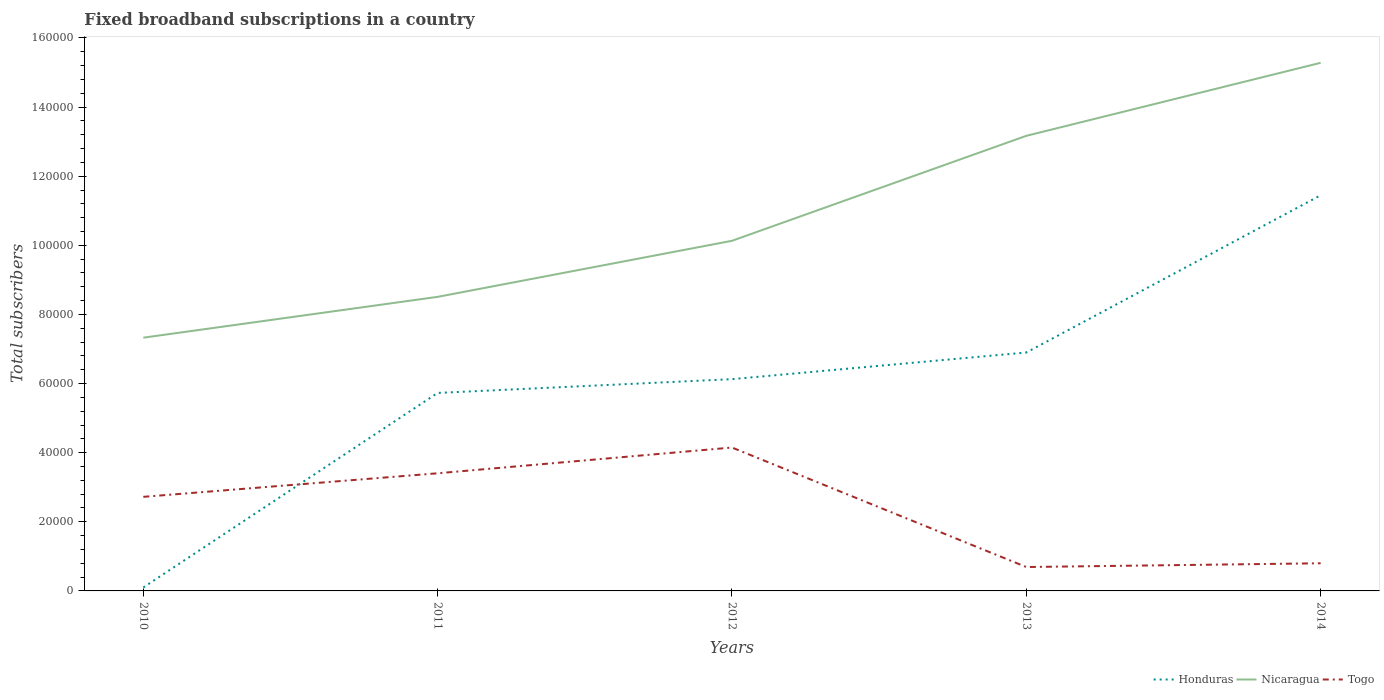How many different coloured lines are there?
Keep it short and to the point. 3. Does the line corresponding to Nicaragua intersect with the line corresponding to Togo?
Give a very brief answer. No. Across all years, what is the maximum number of broadband subscriptions in Honduras?
Your answer should be very brief. 1000. In which year was the number of broadband subscriptions in Nicaragua maximum?
Your response must be concise. 2010. What is the total number of broadband subscriptions in Togo in the graph?
Keep it short and to the point. 2.71e+04. What is the difference between the highest and the second highest number of broadband subscriptions in Togo?
Your answer should be very brief. 3.46e+04. What is the difference between the highest and the lowest number of broadband subscriptions in Togo?
Provide a succinct answer. 3. How many years are there in the graph?
Provide a succinct answer. 5. What is the difference between two consecutive major ticks on the Y-axis?
Provide a succinct answer. 2.00e+04. Are the values on the major ticks of Y-axis written in scientific E-notation?
Offer a very short reply. No. How many legend labels are there?
Keep it short and to the point. 3. What is the title of the graph?
Give a very brief answer. Fixed broadband subscriptions in a country. What is the label or title of the X-axis?
Provide a short and direct response. Years. What is the label or title of the Y-axis?
Offer a terse response. Total subscribers. What is the Total subscribers of Nicaragua in 2010?
Provide a short and direct response. 7.33e+04. What is the Total subscribers of Togo in 2010?
Provide a short and direct response. 2.72e+04. What is the Total subscribers of Honduras in 2011?
Your response must be concise. 5.73e+04. What is the Total subscribers of Nicaragua in 2011?
Provide a succinct answer. 8.51e+04. What is the Total subscribers of Togo in 2011?
Provide a short and direct response. 3.40e+04. What is the Total subscribers of Honduras in 2012?
Your answer should be very brief. 6.13e+04. What is the Total subscribers in Nicaragua in 2012?
Provide a short and direct response. 1.01e+05. What is the Total subscribers in Togo in 2012?
Provide a short and direct response. 4.15e+04. What is the Total subscribers in Honduras in 2013?
Offer a very short reply. 6.90e+04. What is the Total subscribers in Nicaragua in 2013?
Ensure brevity in your answer.  1.32e+05. What is the Total subscribers in Togo in 2013?
Provide a succinct answer. 6915. What is the Total subscribers in Honduras in 2014?
Offer a very short reply. 1.14e+05. What is the Total subscribers in Nicaragua in 2014?
Offer a terse response. 1.53e+05. What is the Total subscribers in Togo in 2014?
Offer a very short reply. 8000. Across all years, what is the maximum Total subscribers of Honduras?
Your response must be concise. 1.14e+05. Across all years, what is the maximum Total subscribers in Nicaragua?
Provide a succinct answer. 1.53e+05. Across all years, what is the maximum Total subscribers in Togo?
Your response must be concise. 4.15e+04. Across all years, what is the minimum Total subscribers in Honduras?
Make the answer very short. 1000. Across all years, what is the minimum Total subscribers of Nicaragua?
Your answer should be very brief. 7.33e+04. Across all years, what is the minimum Total subscribers of Togo?
Make the answer very short. 6915. What is the total Total subscribers of Honduras in the graph?
Offer a terse response. 3.03e+05. What is the total Total subscribers of Nicaragua in the graph?
Provide a succinct answer. 5.44e+05. What is the total Total subscribers of Togo in the graph?
Keep it short and to the point. 1.18e+05. What is the difference between the Total subscribers of Honduras in 2010 and that in 2011?
Offer a terse response. -5.63e+04. What is the difference between the Total subscribers of Nicaragua in 2010 and that in 2011?
Keep it short and to the point. -1.18e+04. What is the difference between the Total subscribers in Togo in 2010 and that in 2011?
Keep it short and to the point. -6814. What is the difference between the Total subscribers of Honduras in 2010 and that in 2012?
Give a very brief answer. -6.03e+04. What is the difference between the Total subscribers of Nicaragua in 2010 and that in 2012?
Your response must be concise. -2.80e+04. What is the difference between the Total subscribers in Togo in 2010 and that in 2012?
Give a very brief answer. -1.43e+04. What is the difference between the Total subscribers in Honduras in 2010 and that in 2013?
Make the answer very short. -6.80e+04. What is the difference between the Total subscribers in Nicaragua in 2010 and that in 2013?
Provide a succinct answer. -5.84e+04. What is the difference between the Total subscribers in Togo in 2010 and that in 2013?
Offer a terse response. 2.03e+04. What is the difference between the Total subscribers of Honduras in 2010 and that in 2014?
Keep it short and to the point. -1.13e+05. What is the difference between the Total subscribers in Nicaragua in 2010 and that in 2014?
Your answer should be very brief. -7.95e+04. What is the difference between the Total subscribers of Togo in 2010 and that in 2014?
Your response must be concise. 1.92e+04. What is the difference between the Total subscribers of Honduras in 2011 and that in 2012?
Give a very brief answer. -3987. What is the difference between the Total subscribers in Nicaragua in 2011 and that in 2012?
Provide a succinct answer. -1.62e+04. What is the difference between the Total subscribers in Togo in 2011 and that in 2012?
Offer a very short reply. -7454. What is the difference between the Total subscribers of Honduras in 2011 and that in 2013?
Your response must be concise. -1.17e+04. What is the difference between the Total subscribers of Nicaragua in 2011 and that in 2013?
Your response must be concise. -4.66e+04. What is the difference between the Total subscribers of Togo in 2011 and that in 2013?
Ensure brevity in your answer.  2.71e+04. What is the difference between the Total subscribers in Honduras in 2011 and that in 2014?
Provide a succinct answer. -5.72e+04. What is the difference between the Total subscribers of Nicaragua in 2011 and that in 2014?
Your answer should be very brief. -6.77e+04. What is the difference between the Total subscribers of Togo in 2011 and that in 2014?
Offer a very short reply. 2.60e+04. What is the difference between the Total subscribers in Honduras in 2012 and that in 2013?
Offer a terse response. -7714. What is the difference between the Total subscribers of Nicaragua in 2012 and that in 2013?
Give a very brief answer. -3.04e+04. What is the difference between the Total subscribers in Togo in 2012 and that in 2013?
Offer a very short reply. 3.46e+04. What is the difference between the Total subscribers in Honduras in 2012 and that in 2014?
Ensure brevity in your answer.  -5.32e+04. What is the difference between the Total subscribers of Nicaragua in 2012 and that in 2014?
Give a very brief answer. -5.15e+04. What is the difference between the Total subscribers in Togo in 2012 and that in 2014?
Keep it short and to the point. 3.35e+04. What is the difference between the Total subscribers of Honduras in 2013 and that in 2014?
Provide a short and direct response. -4.55e+04. What is the difference between the Total subscribers in Nicaragua in 2013 and that in 2014?
Your answer should be compact. -2.11e+04. What is the difference between the Total subscribers of Togo in 2013 and that in 2014?
Keep it short and to the point. -1085. What is the difference between the Total subscribers in Honduras in 2010 and the Total subscribers in Nicaragua in 2011?
Provide a succinct answer. -8.41e+04. What is the difference between the Total subscribers of Honduras in 2010 and the Total subscribers of Togo in 2011?
Ensure brevity in your answer.  -3.30e+04. What is the difference between the Total subscribers of Nicaragua in 2010 and the Total subscribers of Togo in 2011?
Your answer should be very brief. 3.92e+04. What is the difference between the Total subscribers in Honduras in 2010 and the Total subscribers in Nicaragua in 2012?
Provide a short and direct response. -1.00e+05. What is the difference between the Total subscribers in Honduras in 2010 and the Total subscribers in Togo in 2012?
Make the answer very short. -4.05e+04. What is the difference between the Total subscribers in Nicaragua in 2010 and the Total subscribers in Togo in 2012?
Your answer should be very brief. 3.18e+04. What is the difference between the Total subscribers of Honduras in 2010 and the Total subscribers of Nicaragua in 2013?
Give a very brief answer. -1.31e+05. What is the difference between the Total subscribers of Honduras in 2010 and the Total subscribers of Togo in 2013?
Ensure brevity in your answer.  -5915. What is the difference between the Total subscribers of Nicaragua in 2010 and the Total subscribers of Togo in 2013?
Ensure brevity in your answer.  6.64e+04. What is the difference between the Total subscribers of Honduras in 2010 and the Total subscribers of Nicaragua in 2014?
Offer a terse response. -1.52e+05. What is the difference between the Total subscribers in Honduras in 2010 and the Total subscribers in Togo in 2014?
Make the answer very short. -7000. What is the difference between the Total subscribers of Nicaragua in 2010 and the Total subscribers of Togo in 2014?
Give a very brief answer. 6.53e+04. What is the difference between the Total subscribers of Honduras in 2011 and the Total subscribers of Nicaragua in 2012?
Provide a short and direct response. -4.40e+04. What is the difference between the Total subscribers of Honduras in 2011 and the Total subscribers of Togo in 2012?
Keep it short and to the point. 1.58e+04. What is the difference between the Total subscribers of Nicaragua in 2011 and the Total subscribers of Togo in 2012?
Keep it short and to the point. 4.36e+04. What is the difference between the Total subscribers of Honduras in 2011 and the Total subscribers of Nicaragua in 2013?
Offer a terse response. -7.44e+04. What is the difference between the Total subscribers in Honduras in 2011 and the Total subscribers in Togo in 2013?
Offer a very short reply. 5.04e+04. What is the difference between the Total subscribers in Nicaragua in 2011 and the Total subscribers in Togo in 2013?
Give a very brief answer. 7.82e+04. What is the difference between the Total subscribers of Honduras in 2011 and the Total subscribers of Nicaragua in 2014?
Ensure brevity in your answer.  -9.55e+04. What is the difference between the Total subscribers in Honduras in 2011 and the Total subscribers in Togo in 2014?
Provide a succinct answer. 4.93e+04. What is the difference between the Total subscribers of Nicaragua in 2011 and the Total subscribers of Togo in 2014?
Keep it short and to the point. 7.71e+04. What is the difference between the Total subscribers in Honduras in 2012 and the Total subscribers in Nicaragua in 2013?
Offer a terse response. -7.04e+04. What is the difference between the Total subscribers in Honduras in 2012 and the Total subscribers in Togo in 2013?
Give a very brief answer. 5.44e+04. What is the difference between the Total subscribers of Nicaragua in 2012 and the Total subscribers of Togo in 2013?
Give a very brief answer. 9.44e+04. What is the difference between the Total subscribers of Honduras in 2012 and the Total subscribers of Nicaragua in 2014?
Your answer should be compact. -9.15e+04. What is the difference between the Total subscribers in Honduras in 2012 and the Total subscribers in Togo in 2014?
Keep it short and to the point. 5.33e+04. What is the difference between the Total subscribers in Nicaragua in 2012 and the Total subscribers in Togo in 2014?
Provide a short and direct response. 9.33e+04. What is the difference between the Total subscribers in Honduras in 2013 and the Total subscribers in Nicaragua in 2014?
Ensure brevity in your answer.  -8.38e+04. What is the difference between the Total subscribers of Honduras in 2013 and the Total subscribers of Togo in 2014?
Offer a terse response. 6.10e+04. What is the difference between the Total subscribers in Nicaragua in 2013 and the Total subscribers in Togo in 2014?
Offer a very short reply. 1.24e+05. What is the average Total subscribers in Honduras per year?
Your answer should be compact. 6.06e+04. What is the average Total subscribers of Nicaragua per year?
Offer a very short reply. 1.09e+05. What is the average Total subscribers in Togo per year?
Your response must be concise. 2.35e+04. In the year 2010, what is the difference between the Total subscribers in Honduras and Total subscribers in Nicaragua?
Your answer should be very brief. -7.23e+04. In the year 2010, what is the difference between the Total subscribers in Honduras and Total subscribers in Togo?
Make the answer very short. -2.62e+04. In the year 2010, what is the difference between the Total subscribers of Nicaragua and Total subscribers of Togo?
Your response must be concise. 4.61e+04. In the year 2011, what is the difference between the Total subscribers in Honduras and Total subscribers in Nicaragua?
Offer a terse response. -2.78e+04. In the year 2011, what is the difference between the Total subscribers in Honduras and Total subscribers in Togo?
Offer a very short reply. 2.33e+04. In the year 2011, what is the difference between the Total subscribers of Nicaragua and Total subscribers of Togo?
Your answer should be compact. 5.11e+04. In the year 2012, what is the difference between the Total subscribers of Honduras and Total subscribers of Nicaragua?
Offer a terse response. -4.00e+04. In the year 2012, what is the difference between the Total subscribers in Honduras and Total subscribers in Togo?
Give a very brief answer. 1.98e+04. In the year 2012, what is the difference between the Total subscribers of Nicaragua and Total subscribers of Togo?
Offer a terse response. 5.98e+04. In the year 2013, what is the difference between the Total subscribers of Honduras and Total subscribers of Nicaragua?
Your answer should be compact. -6.27e+04. In the year 2013, what is the difference between the Total subscribers in Honduras and Total subscribers in Togo?
Keep it short and to the point. 6.21e+04. In the year 2013, what is the difference between the Total subscribers in Nicaragua and Total subscribers in Togo?
Provide a succinct answer. 1.25e+05. In the year 2014, what is the difference between the Total subscribers in Honduras and Total subscribers in Nicaragua?
Your answer should be very brief. -3.83e+04. In the year 2014, what is the difference between the Total subscribers in Honduras and Total subscribers in Togo?
Give a very brief answer. 1.06e+05. In the year 2014, what is the difference between the Total subscribers of Nicaragua and Total subscribers of Togo?
Ensure brevity in your answer.  1.45e+05. What is the ratio of the Total subscribers in Honduras in 2010 to that in 2011?
Your response must be concise. 0.02. What is the ratio of the Total subscribers in Nicaragua in 2010 to that in 2011?
Your answer should be compact. 0.86. What is the ratio of the Total subscribers of Togo in 2010 to that in 2011?
Provide a succinct answer. 0.8. What is the ratio of the Total subscribers in Honduras in 2010 to that in 2012?
Ensure brevity in your answer.  0.02. What is the ratio of the Total subscribers in Nicaragua in 2010 to that in 2012?
Your response must be concise. 0.72. What is the ratio of the Total subscribers in Togo in 2010 to that in 2012?
Offer a terse response. 0.66. What is the ratio of the Total subscribers in Honduras in 2010 to that in 2013?
Give a very brief answer. 0.01. What is the ratio of the Total subscribers of Nicaragua in 2010 to that in 2013?
Offer a very short reply. 0.56. What is the ratio of the Total subscribers of Togo in 2010 to that in 2013?
Offer a very short reply. 3.94. What is the ratio of the Total subscribers of Honduras in 2010 to that in 2014?
Offer a terse response. 0.01. What is the ratio of the Total subscribers in Nicaragua in 2010 to that in 2014?
Keep it short and to the point. 0.48. What is the ratio of the Total subscribers in Togo in 2010 to that in 2014?
Give a very brief answer. 3.4. What is the ratio of the Total subscribers of Honduras in 2011 to that in 2012?
Make the answer very short. 0.93. What is the ratio of the Total subscribers of Nicaragua in 2011 to that in 2012?
Your answer should be very brief. 0.84. What is the ratio of the Total subscribers of Togo in 2011 to that in 2012?
Your answer should be compact. 0.82. What is the ratio of the Total subscribers in Honduras in 2011 to that in 2013?
Provide a succinct answer. 0.83. What is the ratio of the Total subscribers of Nicaragua in 2011 to that in 2013?
Give a very brief answer. 0.65. What is the ratio of the Total subscribers in Togo in 2011 to that in 2013?
Your answer should be compact. 4.92. What is the ratio of the Total subscribers of Honduras in 2011 to that in 2014?
Provide a succinct answer. 0.5. What is the ratio of the Total subscribers of Nicaragua in 2011 to that in 2014?
Offer a very short reply. 0.56. What is the ratio of the Total subscribers of Togo in 2011 to that in 2014?
Ensure brevity in your answer.  4.25. What is the ratio of the Total subscribers in Honduras in 2012 to that in 2013?
Offer a very short reply. 0.89. What is the ratio of the Total subscribers in Nicaragua in 2012 to that in 2013?
Offer a very short reply. 0.77. What is the ratio of the Total subscribers in Togo in 2012 to that in 2013?
Ensure brevity in your answer.  6. What is the ratio of the Total subscribers of Honduras in 2012 to that in 2014?
Keep it short and to the point. 0.54. What is the ratio of the Total subscribers of Nicaragua in 2012 to that in 2014?
Ensure brevity in your answer.  0.66. What is the ratio of the Total subscribers of Togo in 2012 to that in 2014?
Make the answer very short. 5.19. What is the ratio of the Total subscribers in Honduras in 2013 to that in 2014?
Keep it short and to the point. 0.6. What is the ratio of the Total subscribers in Nicaragua in 2013 to that in 2014?
Keep it short and to the point. 0.86. What is the ratio of the Total subscribers of Togo in 2013 to that in 2014?
Provide a short and direct response. 0.86. What is the difference between the highest and the second highest Total subscribers in Honduras?
Keep it short and to the point. 4.55e+04. What is the difference between the highest and the second highest Total subscribers in Nicaragua?
Provide a short and direct response. 2.11e+04. What is the difference between the highest and the second highest Total subscribers in Togo?
Provide a succinct answer. 7454. What is the difference between the highest and the lowest Total subscribers of Honduras?
Your answer should be very brief. 1.13e+05. What is the difference between the highest and the lowest Total subscribers in Nicaragua?
Your answer should be compact. 7.95e+04. What is the difference between the highest and the lowest Total subscribers of Togo?
Ensure brevity in your answer.  3.46e+04. 